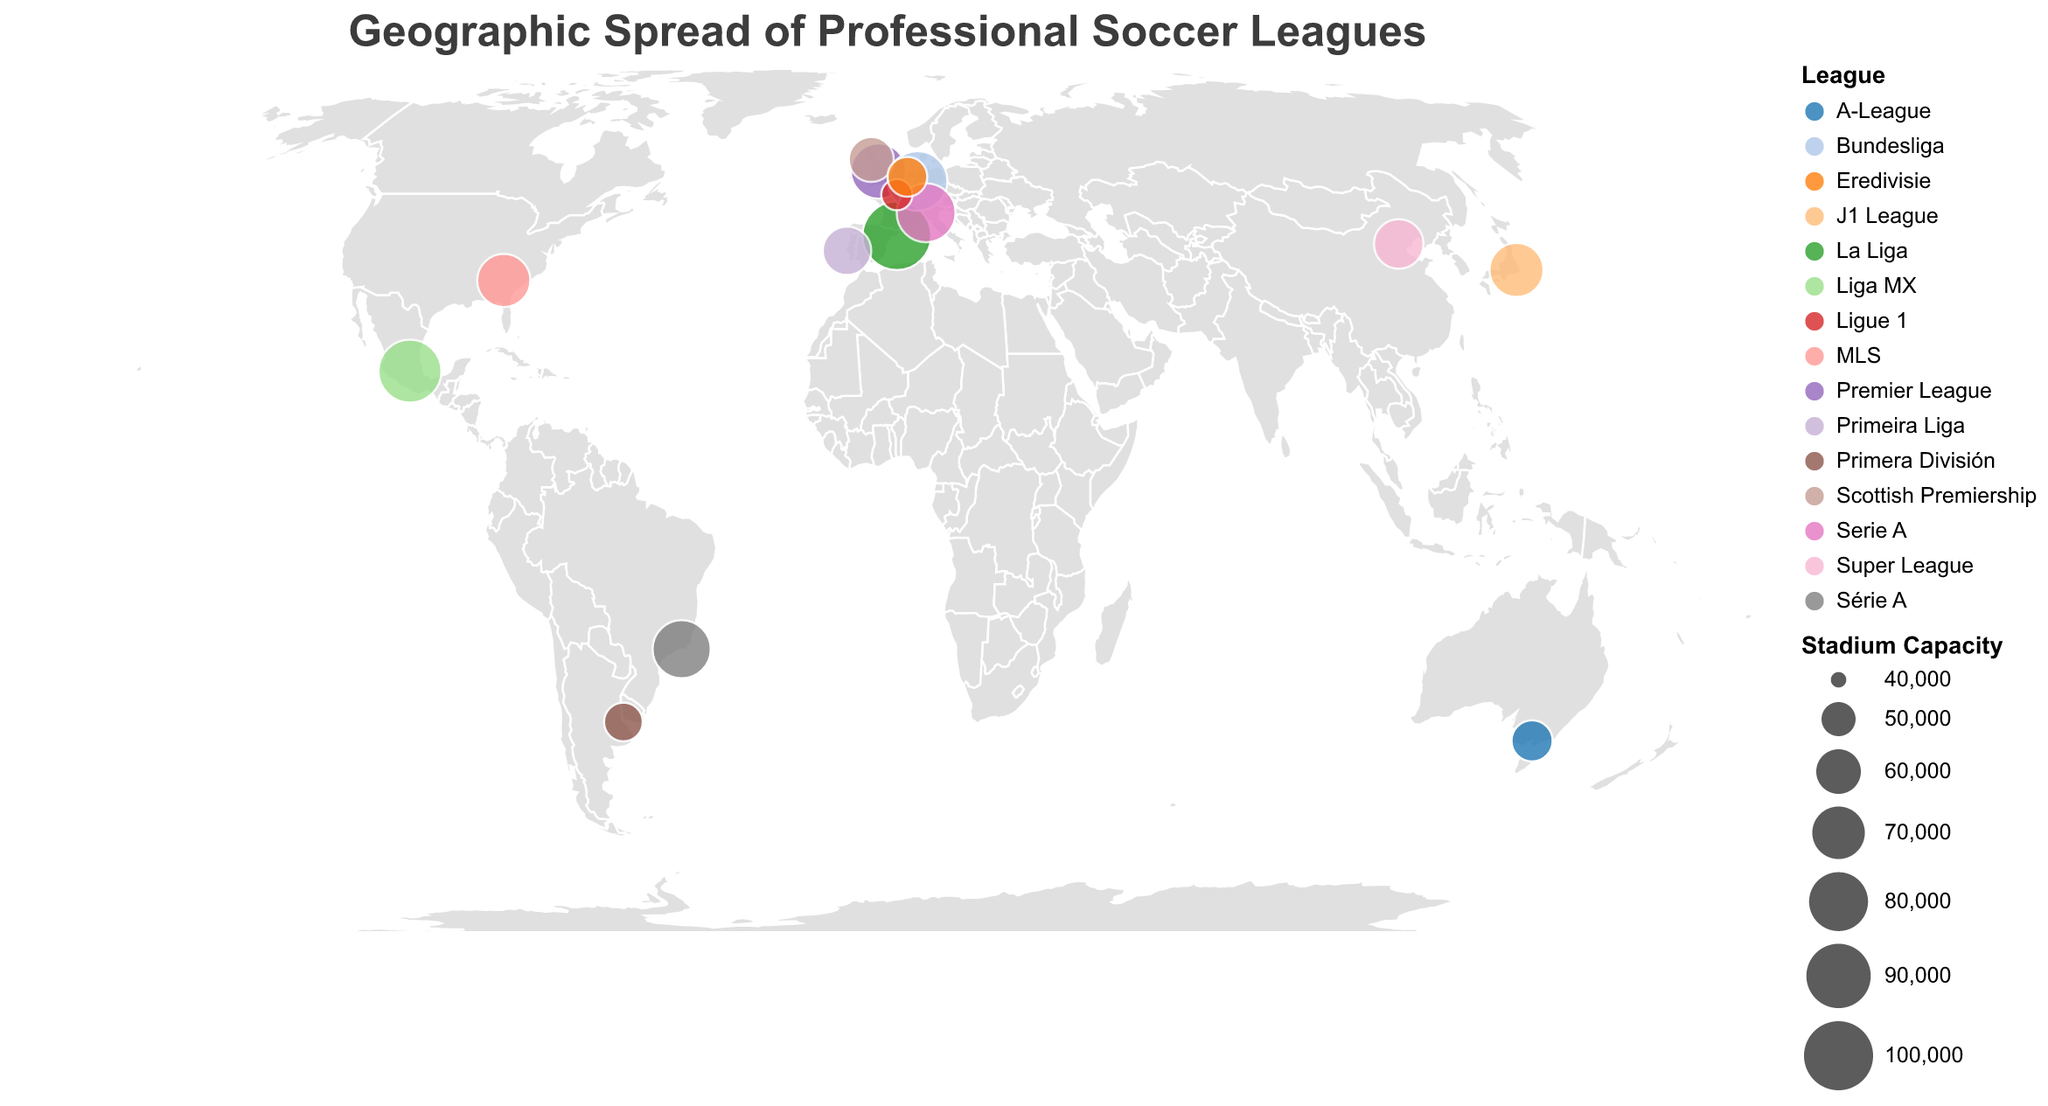What's the largest stadium capacity in the figure? To find the largest stadium capacity, look at the size of the circles and see the capacity in the tooltip. The Camp Nou stadium in Spain (La Liga) has the largest capacity of 99,354.
Answer: 99,354 What's the smallest stadium capacity represented in the figure? The smallest stadium can be found by looking for the smallest circles and checking their tooltips. Parc des Princes in France (Ligue 1) has the smallest capacity of 47,929.
Answer: 47,929 Which stadiums are in the Southern Hemisphere? The Southern Hemisphere includes stadiums located below the equator (latitude < 0). Maracanã in Brazil and La Bombonera in Argentina are located in the Southern Hemisphere.
Answer: Maracanã and La Bombonera How does the stadium capacity of Signal Iduna Park compare to San Siro? Compare the capacities of Signal Iduna Park (81,365) and San Siro (80,018) using the tooltip information. Signal Iduna Park has a higher capacity than San Siro.
Answer: Signal Iduna Park Which country has the highest number of stadiums in the figure? Since each country has one stadium represented, all countries have a count of one stadium each based on the figure's data.
Answer: All countries have one stadium each What is the average capacity of the stadiums shown in the figure? To find the average, sum the capacities (74,140 + 99,354 + 81,365 + 80,018 + 47,929 + 78,838 + 54,000 + 71,000 + 72,327 + 56,347 + 60,411 + 54,990 + 64,642 + 87,523 + 66,000 = 1,048,884) and divide by the number of stadiums (15). The average capacity is 1,048,884 / 15.
Answer: 69,925.6 Which stadium is located furthest west? Look at the longitude values; the stadium with the smallest (most negative) longitude is furthest west. Mercedes-Benz Stadium in the USA (MLS) with a longitude of -84.4006 is furthest west.
Answer: Mercedes-Benz Stadium Are there any stadiums with a capacity between 60,000 and 70,000? Examine the capacities provided: Beijing Workers' Stadium in China (66,000) and Estádio da Luz in Portugal (64,642) fall within this range.
Answer: Beijing Workers' Stadium and Estádio da Luz Which league is represented by Camp Nou? Find Camp Nou on the map using its tooltip. It resides in Spain's La Liga 1.
Answer: La Liga What is the league color correspondence for MLS? Refer to the legend to see the color assigned to each league. MLS is represented by a specific color as per the category scheme reflected in the legend.
Answer: Specific MLS color (e.g., a unique color in the category scheme) Is there any continent without a stadium representation? Review geographic placements, noting all stadiums appear in North America, South America, Europe, Asia, and Australia. Africa and Antarctica do not have any representations.
Answer: Africa and Antarctica 